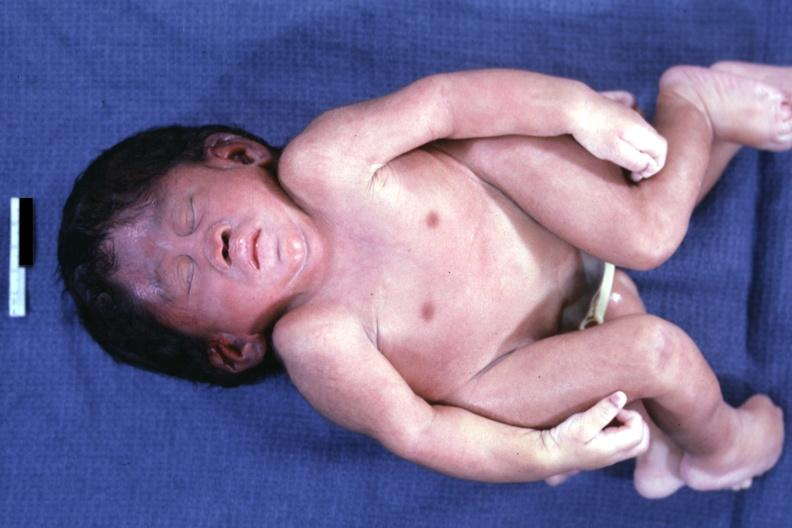what does this image show?
Answer the question using a single word or phrase. Anterior view 